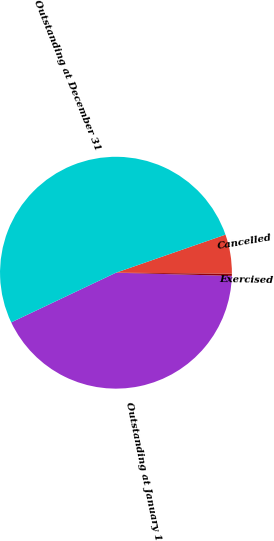Convert chart to OTSL. <chart><loc_0><loc_0><loc_500><loc_500><pie_chart><fcel>Outstanding at January 1<fcel>Exercised<fcel>Cancelled<fcel>Outstanding at December 31<nl><fcel>42.52%<fcel>0.31%<fcel>5.45%<fcel>51.72%<nl></chart> 